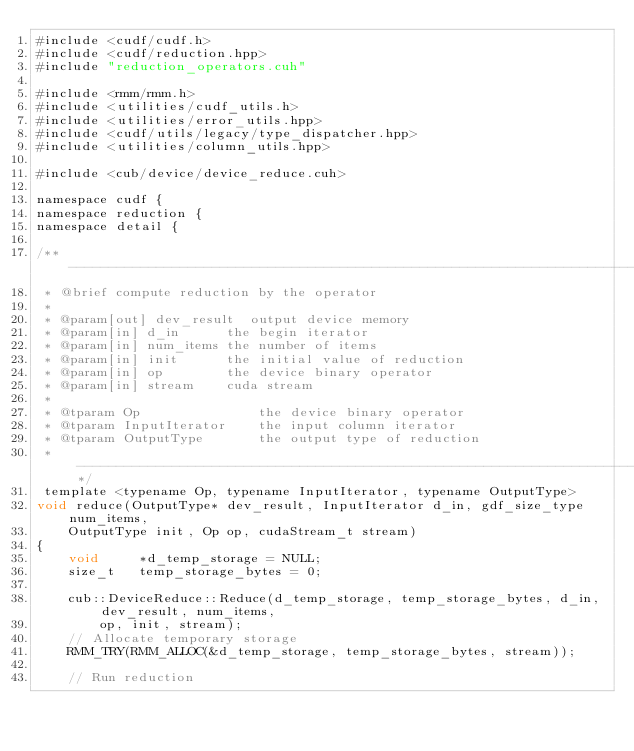<code> <loc_0><loc_0><loc_500><loc_500><_Cuda_>#include <cudf/cudf.h>
#include <cudf/reduction.hpp>
#include "reduction_operators.cuh"

#include <rmm/rmm.h>
#include <utilities/cudf_utils.h>
#include <utilities/error_utils.hpp>
#include <cudf/utils/legacy/type_dispatcher.hpp>
#include <utilities/column_utils.hpp>

#include <cub/device/device_reduce.cuh>

namespace cudf {
namespace reduction {
namespace detail {

/** --------------------------------------------------------------------------*
 * @brief compute reduction by the operator
 *
 * @param[out] dev_result  output device memory
 * @param[in] d_in      the begin iterator
 * @param[in] num_items the number of items
 * @param[in] init      the initial value of reduction
 * @param[in] op        the device binary operator
 * @param[in] stream    cuda stream
 *
 * @tparam Op               the device binary operator
 * @tparam InputIterator    the input column iterator
 * @tparam OutputType       the output type of reduction
 * ----------------------------------------------------------------------------**/
 template <typename Op, typename InputIterator, typename OutputType>
void reduce(OutputType* dev_result, InputIterator d_in, gdf_size_type num_items,
    OutputType init, Op op, cudaStream_t stream)
{
    void     *d_temp_storage = NULL;
    size_t   temp_storage_bytes = 0;

    cub::DeviceReduce::Reduce(d_temp_storage, temp_storage_bytes, d_in, dev_result, num_items,
        op, init, stream);
    // Allocate temporary storage
    RMM_TRY(RMM_ALLOC(&d_temp_storage, temp_storage_bytes, stream));

    // Run reduction</code> 